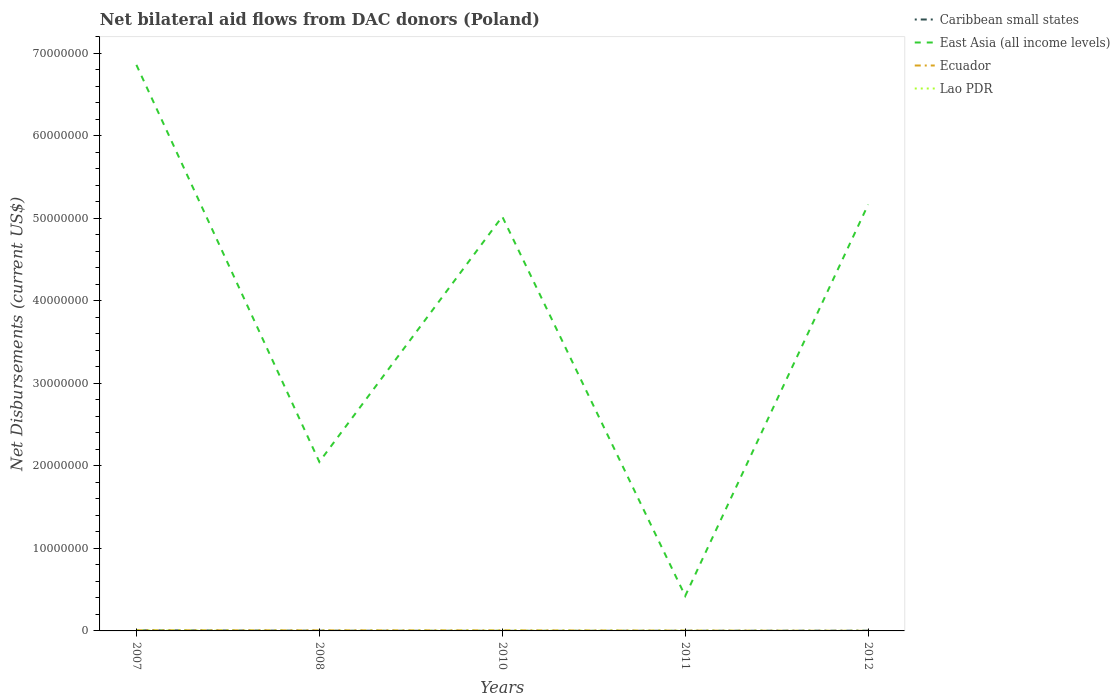How many different coloured lines are there?
Keep it short and to the point. 4. Is the number of lines equal to the number of legend labels?
Your answer should be very brief. Yes. Across all years, what is the maximum net bilateral aid flows in Lao PDR?
Your response must be concise. 10000. What is the total net bilateral aid flows in Ecuador in the graph?
Keep it short and to the point. 3.00e+04. What is the difference between the highest and the second highest net bilateral aid flows in Lao PDR?
Your answer should be compact. 4.00e+04. How many lines are there?
Provide a short and direct response. 4. Does the graph contain any zero values?
Provide a succinct answer. No. Where does the legend appear in the graph?
Offer a very short reply. Top right. How many legend labels are there?
Keep it short and to the point. 4. What is the title of the graph?
Give a very brief answer. Net bilateral aid flows from DAC donors (Poland). What is the label or title of the X-axis?
Offer a terse response. Years. What is the label or title of the Y-axis?
Your answer should be compact. Net Disbursements (current US$). What is the Net Disbursements (current US$) of Caribbean small states in 2007?
Offer a terse response. 7.00e+04. What is the Net Disbursements (current US$) in East Asia (all income levels) in 2007?
Provide a succinct answer. 6.86e+07. What is the Net Disbursements (current US$) in Ecuador in 2007?
Your response must be concise. 8.00e+04. What is the Net Disbursements (current US$) of Lao PDR in 2007?
Your answer should be compact. 5.00e+04. What is the Net Disbursements (current US$) of Caribbean small states in 2008?
Your answer should be very brief. 3.00e+04. What is the Net Disbursements (current US$) of East Asia (all income levels) in 2008?
Provide a succinct answer. 2.05e+07. What is the Net Disbursements (current US$) of Ecuador in 2008?
Ensure brevity in your answer.  7.00e+04. What is the Net Disbursements (current US$) in East Asia (all income levels) in 2010?
Offer a very short reply. 5.02e+07. What is the Net Disbursements (current US$) in Lao PDR in 2010?
Provide a short and direct response. 3.00e+04. What is the Net Disbursements (current US$) of East Asia (all income levels) in 2011?
Ensure brevity in your answer.  4.24e+06. What is the Net Disbursements (current US$) of Ecuador in 2011?
Give a very brief answer. 4.00e+04. What is the Net Disbursements (current US$) of Lao PDR in 2011?
Your response must be concise. 2.00e+04. What is the Net Disbursements (current US$) in Caribbean small states in 2012?
Ensure brevity in your answer.  3.00e+04. What is the Net Disbursements (current US$) in East Asia (all income levels) in 2012?
Your response must be concise. 5.17e+07. Across all years, what is the maximum Net Disbursements (current US$) in East Asia (all income levels)?
Your answer should be compact. 6.86e+07. Across all years, what is the maximum Net Disbursements (current US$) of Ecuador?
Offer a very short reply. 8.00e+04. Across all years, what is the maximum Net Disbursements (current US$) of Lao PDR?
Offer a terse response. 5.00e+04. Across all years, what is the minimum Net Disbursements (current US$) of East Asia (all income levels)?
Give a very brief answer. 4.24e+06. Across all years, what is the minimum Net Disbursements (current US$) of Lao PDR?
Offer a terse response. 10000. What is the total Net Disbursements (current US$) in East Asia (all income levels) in the graph?
Provide a short and direct response. 1.95e+08. What is the total Net Disbursements (current US$) of Ecuador in the graph?
Your answer should be compact. 2.70e+05. What is the total Net Disbursements (current US$) of Lao PDR in the graph?
Make the answer very short. 1.20e+05. What is the difference between the Net Disbursements (current US$) in East Asia (all income levels) in 2007 and that in 2008?
Provide a short and direct response. 4.81e+07. What is the difference between the Net Disbursements (current US$) of Lao PDR in 2007 and that in 2008?
Offer a terse response. 4.00e+04. What is the difference between the Net Disbursements (current US$) in East Asia (all income levels) in 2007 and that in 2010?
Ensure brevity in your answer.  1.84e+07. What is the difference between the Net Disbursements (current US$) of Ecuador in 2007 and that in 2010?
Ensure brevity in your answer.  10000. What is the difference between the Net Disbursements (current US$) in East Asia (all income levels) in 2007 and that in 2011?
Your response must be concise. 6.43e+07. What is the difference between the Net Disbursements (current US$) of Ecuador in 2007 and that in 2011?
Ensure brevity in your answer.  4.00e+04. What is the difference between the Net Disbursements (current US$) in Caribbean small states in 2007 and that in 2012?
Your answer should be compact. 4.00e+04. What is the difference between the Net Disbursements (current US$) of East Asia (all income levels) in 2007 and that in 2012?
Make the answer very short. 1.69e+07. What is the difference between the Net Disbursements (current US$) in Ecuador in 2007 and that in 2012?
Keep it short and to the point. 7.00e+04. What is the difference between the Net Disbursements (current US$) of East Asia (all income levels) in 2008 and that in 2010?
Give a very brief answer. -2.97e+07. What is the difference between the Net Disbursements (current US$) in Ecuador in 2008 and that in 2010?
Give a very brief answer. 0. What is the difference between the Net Disbursements (current US$) of Lao PDR in 2008 and that in 2010?
Your answer should be very brief. -2.00e+04. What is the difference between the Net Disbursements (current US$) in Caribbean small states in 2008 and that in 2011?
Your answer should be compact. 10000. What is the difference between the Net Disbursements (current US$) in East Asia (all income levels) in 2008 and that in 2011?
Your answer should be very brief. 1.62e+07. What is the difference between the Net Disbursements (current US$) in Ecuador in 2008 and that in 2011?
Your response must be concise. 3.00e+04. What is the difference between the Net Disbursements (current US$) in Caribbean small states in 2008 and that in 2012?
Your answer should be compact. 0. What is the difference between the Net Disbursements (current US$) of East Asia (all income levels) in 2008 and that in 2012?
Give a very brief answer. -3.12e+07. What is the difference between the Net Disbursements (current US$) of Lao PDR in 2008 and that in 2012?
Offer a terse response. 0. What is the difference between the Net Disbursements (current US$) of Caribbean small states in 2010 and that in 2011?
Provide a short and direct response. -10000. What is the difference between the Net Disbursements (current US$) in East Asia (all income levels) in 2010 and that in 2011?
Ensure brevity in your answer.  4.60e+07. What is the difference between the Net Disbursements (current US$) of Ecuador in 2010 and that in 2011?
Your response must be concise. 3.00e+04. What is the difference between the Net Disbursements (current US$) in Caribbean small states in 2010 and that in 2012?
Provide a short and direct response. -2.00e+04. What is the difference between the Net Disbursements (current US$) in East Asia (all income levels) in 2010 and that in 2012?
Provide a short and direct response. -1.46e+06. What is the difference between the Net Disbursements (current US$) of Lao PDR in 2010 and that in 2012?
Offer a very short reply. 2.00e+04. What is the difference between the Net Disbursements (current US$) of Caribbean small states in 2011 and that in 2012?
Give a very brief answer. -10000. What is the difference between the Net Disbursements (current US$) in East Asia (all income levels) in 2011 and that in 2012?
Your response must be concise. -4.74e+07. What is the difference between the Net Disbursements (current US$) in Ecuador in 2011 and that in 2012?
Provide a short and direct response. 3.00e+04. What is the difference between the Net Disbursements (current US$) of Caribbean small states in 2007 and the Net Disbursements (current US$) of East Asia (all income levels) in 2008?
Provide a succinct answer. -2.04e+07. What is the difference between the Net Disbursements (current US$) of Caribbean small states in 2007 and the Net Disbursements (current US$) of Ecuador in 2008?
Offer a terse response. 0. What is the difference between the Net Disbursements (current US$) in Caribbean small states in 2007 and the Net Disbursements (current US$) in Lao PDR in 2008?
Your answer should be compact. 6.00e+04. What is the difference between the Net Disbursements (current US$) of East Asia (all income levels) in 2007 and the Net Disbursements (current US$) of Ecuador in 2008?
Your response must be concise. 6.85e+07. What is the difference between the Net Disbursements (current US$) in East Asia (all income levels) in 2007 and the Net Disbursements (current US$) in Lao PDR in 2008?
Ensure brevity in your answer.  6.86e+07. What is the difference between the Net Disbursements (current US$) of Caribbean small states in 2007 and the Net Disbursements (current US$) of East Asia (all income levels) in 2010?
Offer a terse response. -5.01e+07. What is the difference between the Net Disbursements (current US$) of Caribbean small states in 2007 and the Net Disbursements (current US$) of Ecuador in 2010?
Provide a succinct answer. 0. What is the difference between the Net Disbursements (current US$) of East Asia (all income levels) in 2007 and the Net Disbursements (current US$) of Ecuador in 2010?
Your answer should be compact. 6.85e+07. What is the difference between the Net Disbursements (current US$) in East Asia (all income levels) in 2007 and the Net Disbursements (current US$) in Lao PDR in 2010?
Provide a short and direct response. 6.86e+07. What is the difference between the Net Disbursements (current US$) of Ecuador in 2007 and the Net Disbursements (current US$) of Lao PDR in 2010?
Provide a succinct answer. 5.00e+04. What is the difference between the Net Disbursements (current US$) of Caribbean small states in 2007 and the Net Disbursements (current US$) of East Asia (all income levels) in 2011?
Offer a terse response. -4.17e+06. What is the difference between the Net Disbursements (current US$) in East Asia (all income levels) in 2007 and the Net Disbursements (current US$) in Ecuador in 2011?
Your response must be concise. 6.85e+07. What is the difference between the Net Disbursements (current US$) in East Asia (all income levels) in 2007 and the Net Disbursements (current US$) in Lao PDR in 2011?
Keep it short and to the point. 6.86e+07. What is the difference between the Net Disbursements (current US$) of Caribbean small states in 2007 and the Net Disbursements (current US$) of East Asia (all income levels) in 2012?
Provide a short and direct response. -5.16e+07. What is the difference between the Net Disbursements (current US$) of Caribbean small states in 2007 and the Net Disbursements (current US$) of Lao PDR in 2012?
Keep it short and to the point. 6.00e+04. What is the difference between the Net Disbursements (current US$) in East Asia (all income levels) in 2007 and the Net Disbursements (current US$) in Ecuador in 2012?
Your response must be concise. 6.86e+07. What is the difference between the Net Disbursements (current US$) of East Asia (all income levels) in 2007 and the Net Disbursements (current US$) of Lao PDR in 2012?
Your response must be concise. 6.86e+07. What is the difference between the Net Disbursements (current US$) of Caribbean small states in 2008 and the Net Disbursements (current US$) of East Asia (all income levels) in 2010?
Provide a succinct answer. -5.02e+07. What is the difference between the Net Disbursements (current US$) of Caribbean small states in 2008 and the Net Disbursements (current US$) of Ecuador in 2010?
Make the answer very short. -4.00e+04. What is the difference between the Net Disbursements (current US$) in East Asia (all income levels) in 2008 and the Net Disbursements (current US$) in Ecuador in 2010?
Your answer should be very brief. 2.04e+07. What is the difference between the Net Disbursements (current US$) in East Asia (all income levels) in 2008 and the Net Disbursements (current US$) in Lao PDR in 2010?
Ensure brevity in your answer.  2.04e+07. What is the difference between the Net Disbursements (current US$) in Ecuador in 2008 and the Net Disbursements (current US$) in Lao PDR in 2010?
Ensure brevity in your answer.  4.00e+04. What is the difference between the Net Disbursements (current US$) of Caribbean small states in 2008 and the Net Disbursements (current US$) of East Asia (all income levels) in 2011?
Ensure brevity in your answer.  -4.21e+06. What is the difference between the Net Disbursements (current US$) in East Asia (all income levels) in 2008 and the Net Disbursements (current US$) in Ecuador in 2011?
Give a very brief answer. 2.04e+07. What is the difference between the Net Disbursements (current US$) of East Asia (all income levels) in 2008 and the Net Disbursements (current US$) of Lao PDR in 2011?
Offer a terse response. 2.05e+07. What is the difference between the Net Disbursements (current US$) in Ecuador in 2008 and the Net Disbursements (current US$) in Lao PDR in 2011?
Your answer should be very brief. 5.00e+04. What is the difference between the Net Disbursements (current US$) of Caribbean small states in 2008 and the Net Disbursements (current US$) of East Asia (all income levels) in 2012?
Ensure brevity in your answer.  -5.16e+07. What is the difference between the Net Disbursements (current US$) of East Asia (all income levels) in 2008 and the Net Disbursements (current US$) of Ecuador in 2012?
Provide a succinct answer. 2.05e+07. What is the difference between the Net Disbursements (current US$) of East Asia (all income levels) in 2008 and the Net Disbursements (current US$) of Lao PDR in 2012?
Keep it short and to the point. 2.05e+07. What is the difference between the Net Disbursements (current US$) in Ecuador in 2008 and the Net Disbursements (current US$) in Lao PDR in 2012?
Your answer should be compact. 6.00e+04. What is the difference between the Net Disbursements (current US$) in Caribbean small states in 2010 and the Net Disbursements (current US$) in East Asia (all income levels) in 2011?
Offer a very short reply. -4.23e+06. What is the difference between the Net Disbursements (current US$) of Caribbean small states in 2010 and the Net Disbursements (current US$) of Ecuador in 2011?
Your response must be concise. -3.00e+04. What is the difference between the Net Disbursements (current US$) in East Asia (all income levels) in 2010 and the Net Disbursements (current US$) in Ecuador in 2011?
Make the answer very short. 5.02e+07. What is the difference between the Net Disbursements (current US$) in East Asia (all income levels) in 2010 and the Net Disbursements (current US$) in Lao PDR in 2011?
Your response must be concise. 5.02e+07. What is the difference between the Net Disbursements (current US$) of Ecuador in 2010 and the Net Disbursements (current US$) of Lao PDR in 2011?
Provide a short and direct response. 5.00e+04. What is the difference between the Net Disbursements (current US$) in Caribbean small states in 2010 and the Net Disbursements (current US$) in East Asia (all income levels) in 2012?
Provide a succinct answer. -5.16e+07. What is the difference between the Net Disbursements (current US$) of Caribbean small states in 2010 and the Net Disbursements (current US$) of Ecuador in 2012?
Give a very brief answer. 0. What is the difference between the Net Disbursements (current US$) of East Asia (all income levels) in 2010 and the Net Disbursements (current US$) of Ecuador in 2012?
Keep it short and to the point. 5.02e+07. What is the difference between the Net Disbursements (current US$) in East Asia (all income levels) in 2010 and the Net Disbursements (current US$) in Lao PDR in 2012?
Make the answer very short. 5.02e+07. What is the difference between the Net Disbursements (current US$) in Ecuador in 2010 and the Net Disbursements (current US$) in Lao PDR in 2012?
Provide a succinct answer. 6.00e+04. What is the difference between the Net Disbursements (current US$) in Caribbean small states in 2011 and the Net Disbursements (current US$) in East Asia (all income levels) in 2012?
Keep it short and to the point. -5.16e+07. What is the difference between the Net Disbursements (current US$) of Caribbean small states in 2011 and the Net Disbursements (current US$) of Ecuador in 2012?
Provide a short and direct response. 10000. What is the difference between the Net Disbursements (current US$) of East Asia (all income levels) in 2011 and the Net Disbursements (current US$) of Ecuador in 2012?
Keep it short and to the point. 4.23e+06. What is the difference between the Net Disbursements (current US$) in East Asia (all income levels) in 2011 and the Net Disbursements (current US$) in Lao PDR in 2012?
Make the answer very short. 4.23e+06. What is the average Net Disbursements (current US$) in Caribbean small states per year?
Offer a very short reply. 3.20e+04. What is the average Net Disbursements (current US$) of East Asia (all income levels) per year?
Ensure brevity in your answer.  3.90e+07. What is the average Net Disbursements (current US$) in Ecuador per year?
Your answer should be compact. 5.40e+04. What is the average Net Disbursements (current US$) of Lao PDR per year?
Provide a short and direct response. 2.40e+04. In the year 2007, what is the difference between the Net Disbursements (current US$) of Caribbean small states and Net Disbursements (current US$) of East Asia (all income levels)?
Your answer should be compact. -6.85e+07. In the year 2007, what is the difference between the Net Disbursements (current US$) of Caribbean small states and Net Disbursements (current US$) of Ecuador?
Offer a terse response. -10000. In the year 2007, what is the difference between the Net Disbursements (current US$) of East Asia (all income levels) and Net Disbursements (current US$) of Ecuador?
Offer a very short reply. 6.85e+07. In the year 2007, what is the difference between the Net Disbursements (current US$) of East Asia (all income levels) and Net Disbursements (current US$) of Lao PDR?
Ensure brevity in your answer.  6.85e+07. In the year 2007, what is the difference between the Net Disbursements (current US$) of Ecuador and Net Disbursements (current US$) of Lao PDR?
Offer a terse response. 3.00e+04. In the year 2008, what is the difference between the Net Disbursements (current US$) in Caribbean small states and Net Disbursements (current US$) in East Asia (all income levels)?
Your answer should be compact. -2.04e+07. In the year 2008, what is the difference between the Net Disbursements (current US$) in Caribbean small states and Net Disbursements (current US$) in Lao PDR?
Provide a succinct answer. 2.00e+04. In the year 2008, what is the difference between the Net Disbursements (current US$) in East Asia (all income levels) and Net Disbursements (current US$) in Ecuador?
Make the answer very short. 2.04e+07. In the year 2008, what is the difference between the Net Disbursements (current US$) in East Asia (all income levels) and Net Disbursements (current US$) in Lao PDR?
Give a very brief answer. 2.05e+07. In the year 2010, what is the difference between the Net Disbursements (current US$) of Caribbean small states and Net Disbursements (current US$) of East Asia (all income levels)?
Offer a very short reply. -5.02e+07. In the year 2010, what is the difference between the Net Disbursements (current US$) in Caribbean small states and Net Disbursements (current US$) in Ecuador?
Provide a short and direct response. -6.00e+04. In the year 2010, what is the difference between the Net Disbursements (current US$) of Caribbean small states and Net Disbursements (current US$) of Lao PDR?
Your response must be concise. -2.00e+04. In the year 2010, what is the difference between the Net Disbursements (current US$) of East Asia (all income levels) and Net Disbursements (current US$) of Ecuador?
Offer a very short reply. 5.01e+07. In the year 2010, what is the difference between the Net Disbursements (current US$) in East Asia (all income levels) and Net Disbursements (current US$) in Lao PDR?
Provide a short and direct response. 5.02e+07. In the year 2010, what is the difference between the Net Disbursements (current US$) of Ecuador and Net Disbursements (current US$) of Lao PDR?
Your answer should be compact. 4.00e+04. In the year 2011, what is the difference between the Net Disbursements (current US$) of Caribbean small states and Net Disbursements (current US$) of East Asia (all income levels)?
Make the answer very short. -4.22e+06. In the year 2011, what is the difference between the Net Disbursements (current US$) of Caribbean small states and Net Disbursements (current US$) of Ecuador?
Give a very brief answer. -2.00e+04. In the year 2011, what is the difference between the Net Disbursements (current US$) of East Asia (all income levels) and Net Disbursements (current US$) of Ecuador?
Provide a succinct answer. 4.20e+06. In the year 2011, what is the difference between the Net Disbursements (current US$) of East Asia (all income levels) and Net Disbursements (current US$) of Lao PDR?
Provide a short and direct response. 4.22e+06. In the year 2012, what is the difference between the Net Disbursements (current US$) of Caribbean small states and Net Disbursements (current US$) of East Asia (all income levels)?
Your answer should be very brief. -5.16e+07. In the year 2012, what is the difference between the Net Disbursements (current US$) in Caribbean small states and Net Disbursements (current US$) in Lao PDR?
Provide a short and direct response. 2.00e+04. In the year 2012, what is the difference between the Net Disbursements (current US$) of East Asia (all income levels) and Net Disbursements (current US$) of Ecuador?
Your response must be concise. 5.16e+07. In the year 2012, what is the difference between the Net Disbursements (current US$) of East Asia (all income levels) and Net Disbursements (current US$) of Lao PDR?
Provide a succinct answer. 5.16e+07. In the year 2012, what is the difference between the Net Disbursements (current US$) of Ecuador and Net Disbursements (current US$) of Lao PDR?
Your response must be concise. 0. What is the ratio of the Net Disbursements (current US$) in Caribbean small states in 2007 to that in 2008?
Your answer should be compact. 2.33. What is the ratio of the Net Disbursements (current US$) of East Asia (all income levels) in 2007 to that in 2008?
Ensure brevity in your answer.  3.35. What is the ratio of the Net Disbursements (current US$) of Ecuador in 2007 to that in 2008?
Your answer should be very brief. 1.14. What is the ratio of the Net Disbursements (current US$) of Lao PDR in 2007 to that in 2008?
Keep it short and to the point. 5. What is the ratio of the Net Disbursements (current US$) in East Asia (all income levels) in 2007 to that in 2010?
Ensure brevity in your answer.  1.37. What is the ratio of the Net Disbursements (current US$) in Ecuador in 2007 to that in 2010?
Your answer should be compact. 1.14. What is the ratio of the Net Disbursements (current US$) of Lao PDR in 2007 to that in 2010?
Offer a very short reply. 1.67. What is the ratio of the Net Disbursements (current US$) in East Asia (all income levels) in 2007 to that in 2011?
Keep it short and to the point. 16.17. What is the ratio of the Net Disbursements (current US$) of Lao PDR in 2007 to that in 2011?
Your answer should be very brief. 2.5. What is the ratio of the Net Disbursements (current US$) in Caribbean small states in 2007 to that in 2012?
Your answer should be compact. 2.33. What is the ratio of the Net Disbursements (current US$) in East Asia (all income levels) in 2007 to that in 2012?
Provide a short and direct response. 1.33. What is the ratio of the Net Disbursements (current US$) in Ecuador in 2007 to that in 2012?
Give a very brief answer. 8. What is the ratio of the Net Disbursements (current US$) in Caribbean small states in 2008 to that in 2010?
Make the answer very short. 3. What is the ratio of the Net Disbursements (current US$) in East Asia (all income levels) in 2008 to that in 2010?
Your answer should be compact. 0.41. What is the ratio of the Net Disbursements (current US$) of Ecuador in 2008 to that in 2010?
Give a very brief answer. 1. What is the ratio of the Net Disbursements (current US$) of East Asia (all income levels) in 2008 to that in 2011?
Make the answer very short. 4.83. What is the ratio of the Net Disbursements (current US$) in Ecuador in 2008 to that in 2011?
Ensure brevity in your answer.  1.75. What is the ratio of the Net Disbursements (current US$) in Lao PDR in 2008 to that in 2011?
Provide a short and direct response. 0.5. What is the ratio of the Net Disbursements (current US$) of Caribbean small states in 2008 to that in 2012?
Make the answer very short. 1. What is the ratio of the Net Disbursements (current US$) in East Asia (all income levels) in 2008 to that in 2012?
Offer a very short reply. 0.4. What is the ratio of the Net Disbursements (current US$) in Lao PDR in 2008 to that in 2012?
Your answer should be compact. 1. What is the ratio of the Net Disbursements (current US$) in East Asia (all income levels) in 2010 to that in 2011?
Provide a succinct answer. 11.84. What is the ratio of the Net Disbursements (current US$) in Lao PDR in 2010 to that in 2011?
Keep it short and to the point. 1.5. What is the ratio of the Net Disbursements (current US$) of East Asia (all income levels) in 2010 to that in 2012?
Provide a short and direct response. 0.97. What is the ratio of the Net Disbursements (current US$) of Lao PDR in 2010 to that in 2012?
Keep it short and to the point. 3. What is the ratio of the Net Disbursements (current US$) in Caribbean small states in 2011 to that in 2012?
Give a very brief answer. 0.67. What is the ratio of the Net Disbursements (current US$) in East Asia (all income levels) in 2011 to that in 2012?
Offer a very short reply. 0.08. What is the ratio of the Net Disbursements (current US$) of Ecuador in 2011 to that in 2012?
Provide a succinct answer. 4. What is the difference between the highest and the second highest Net Disbursements (current US$) of Caribbean small states?
Keep it short and to the point. 4.00e+04. What is the difference between the highest and the second highest Net Disbursements (current US$) in East Asia (all income levels)?
Provide a short and direct response. 1.69e+07. What is the difference between the highest and the second highest Net Disbursements (current US$) of Ecuador?
Offer a very short reply. 10000. What is the difference between the highest and the lowest Net Disbursements (current US$) of Caribbean small states?
Give a very brief answer. 6.00e+04. What is the difference between the highest and the lowest Net Disbursements (current US$) in East Asia (all income levels)?
Your answer should be compact. 6.43e+07. 